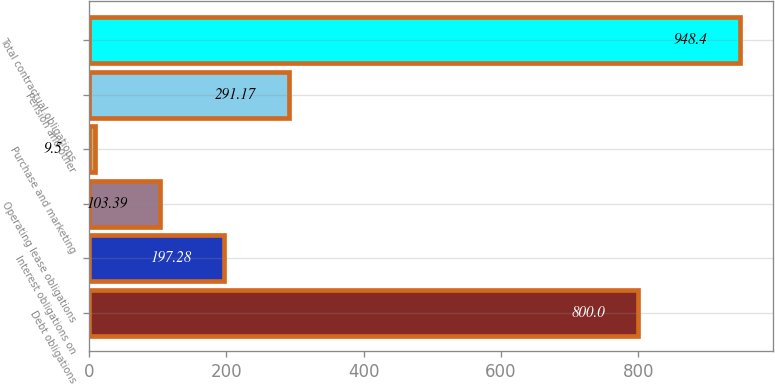Convert chart to OTSL. <chart><loc_0><loc_0><loc_500><loc_500><bar_chart><fcel>Debt obligations<fcel>Interest obligations on<fcel>Operating lease obligations<fcel>Purchase and marketing<fcel>Pension and other<fcel>Total contractual obligations<nl><fcel>800<fcel>197.28<fcel>103.39<fcel>9.5<fcel>291.17<fcel>948.4<nl></chart> 